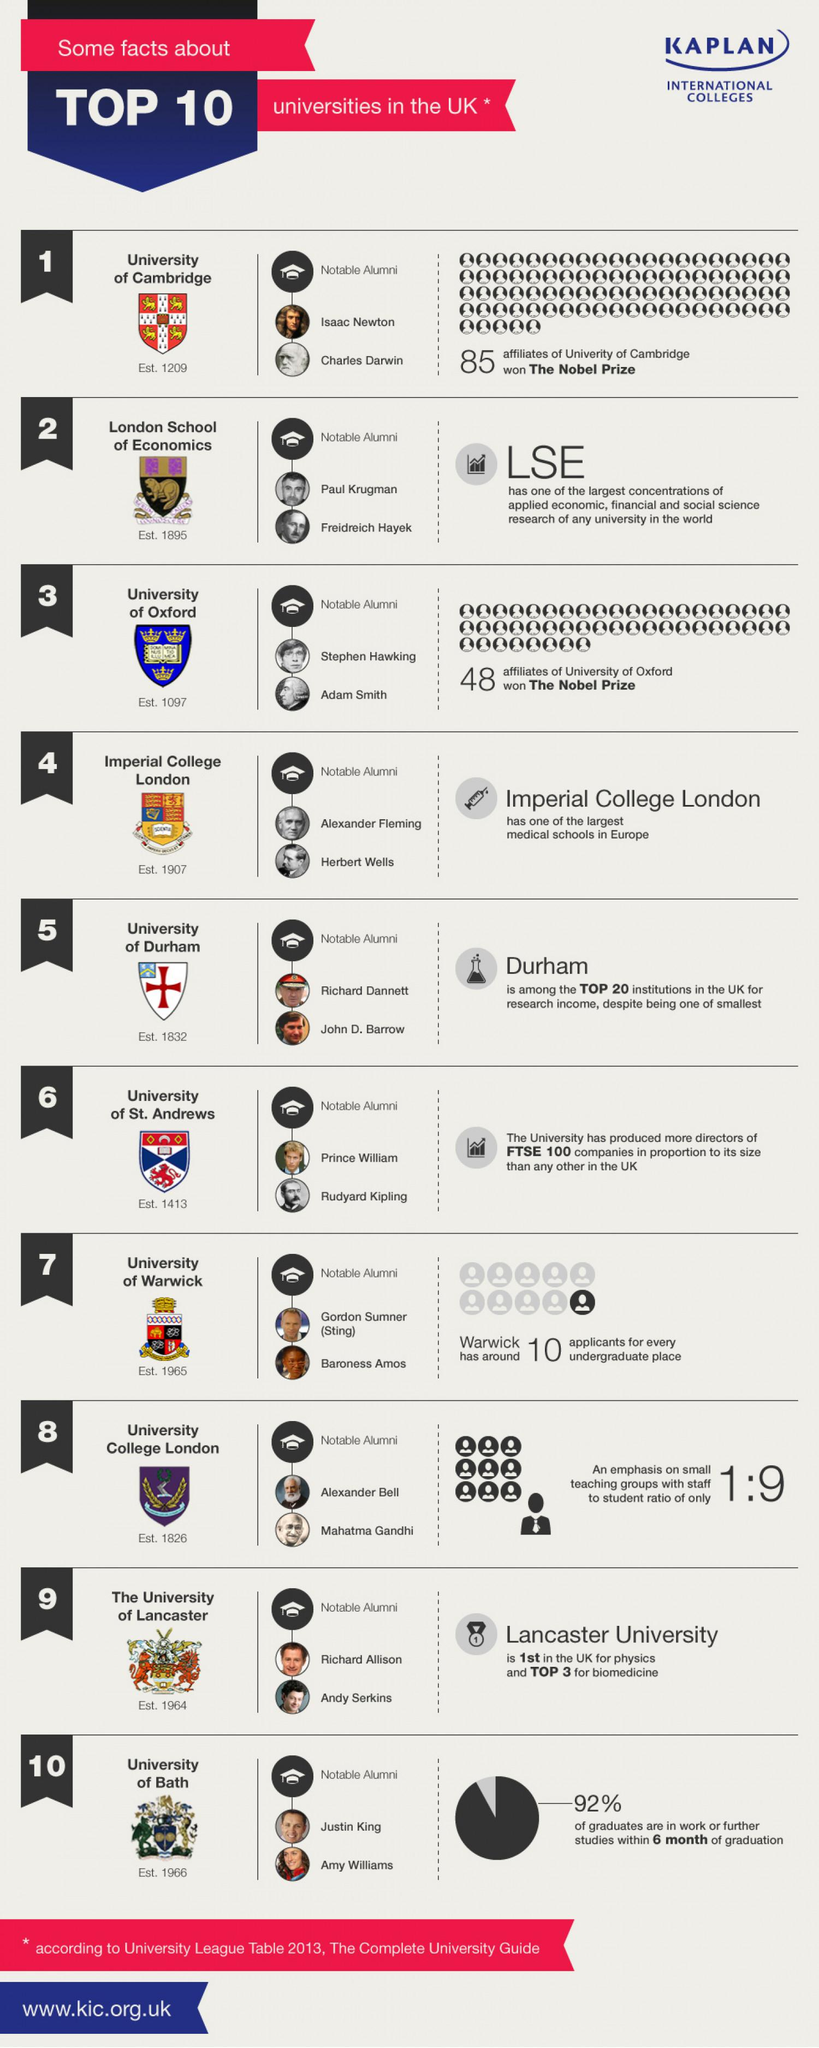Mention a couple of crucial points in this snapshot. Rudyard Kipling was a member of the University of St. Andrews. Mahatma Gandhi, an Indian leader and alumnus of University College London, is known for his leadership and contributions to the country's independence movement. Isaac Newton and Charles Darwin were both part of the University of Cambridge. The University of Cambridge had more affiliates winning the Nobel Prize among those listed. Prince William, a member of the British royal family, is included in the list of notable alumni. 